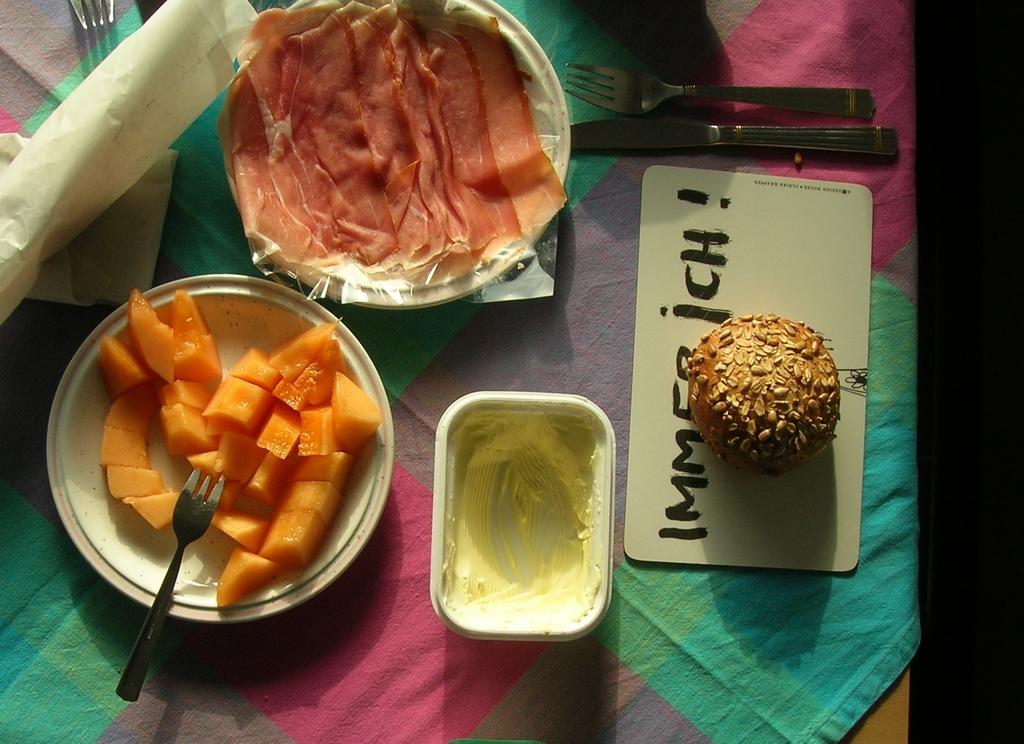Could you give a brief overview of what you see in this image? In this picture we can see plates with food items on it, fork, knife, bowl, papers, cloth and these all are placed on a table. 